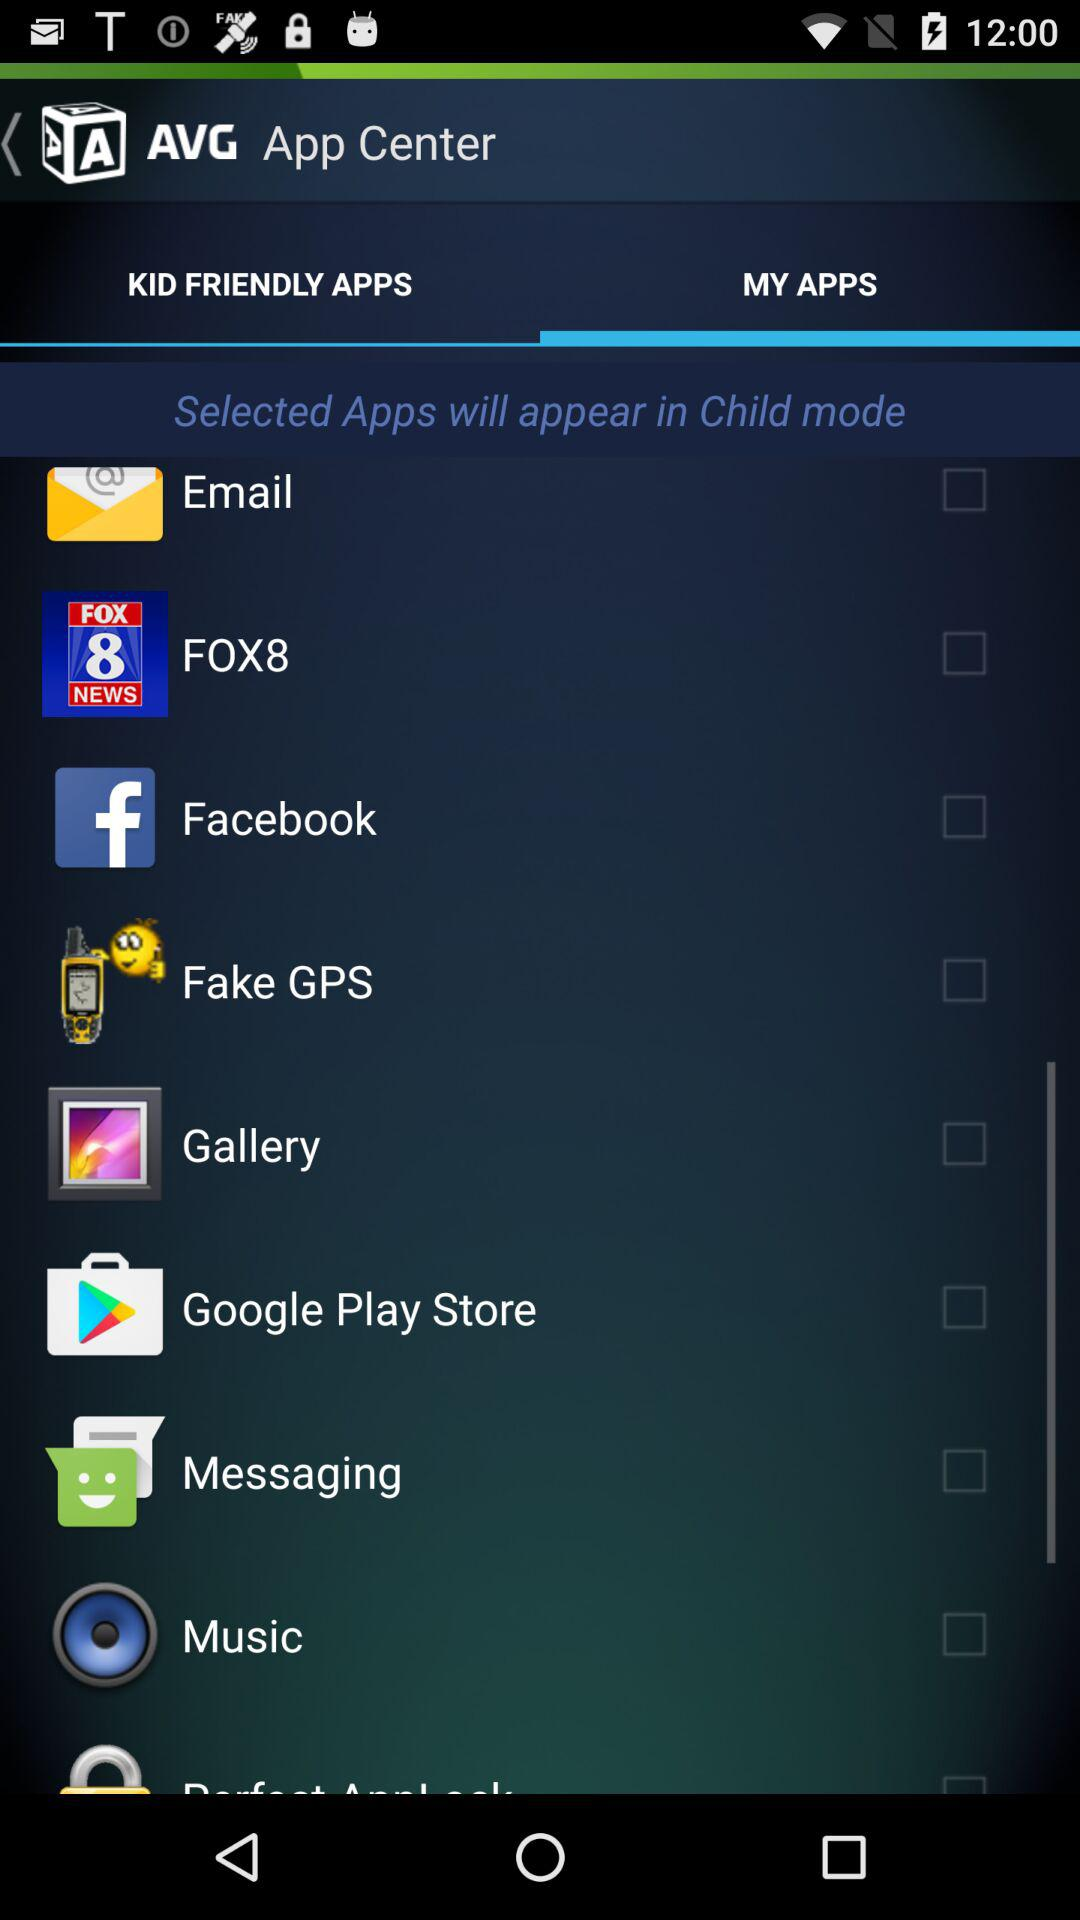What are the different options in "MY APPS"? The different options in "MY APPS" are "Email", "FOX8", "Facebook", "Fake GPS", "Gallery", "Google Play Store", "Messaging" and "Music". 